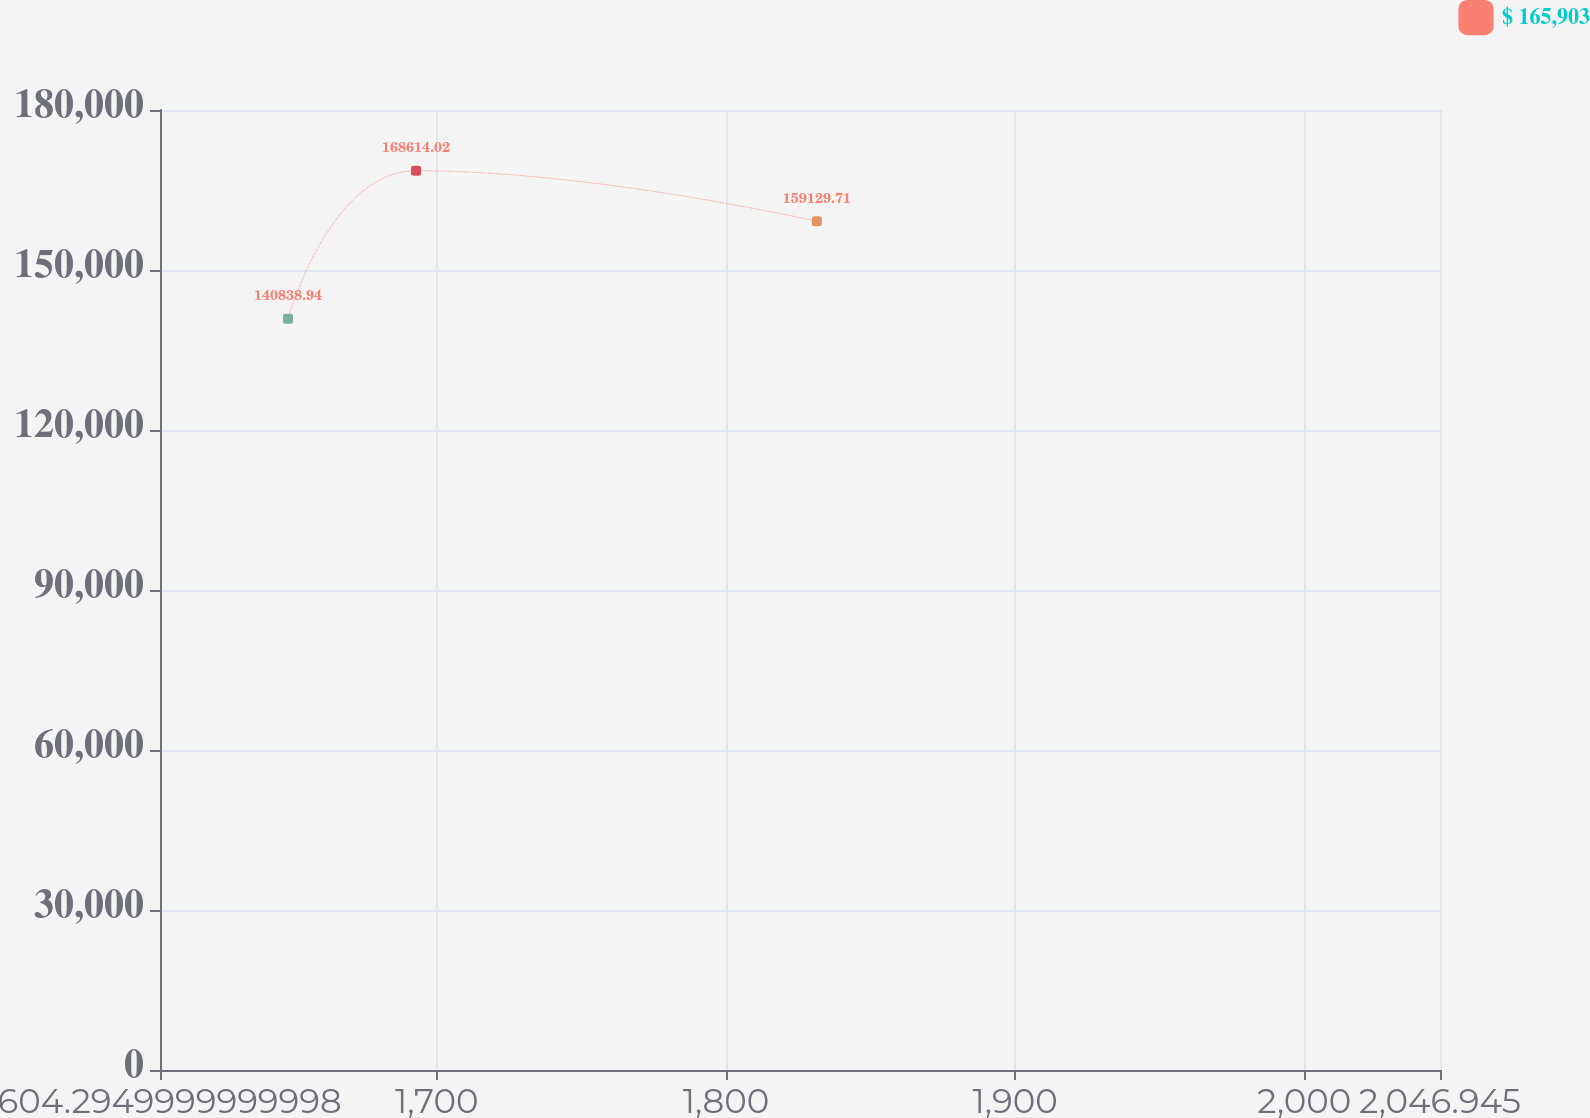Convert chart. <chart><loc_0><loc_0><loc_500><loc_500><line_chart><ecel><fcel>$ 165,903<nl><fcel>1648.56<fcel>140839<nl><fcel>1692.83<fcel>168614<nl><fcel>1831.45<fcel>159130<nl><fcel>2091.21<fcel>136198<nl></chart> 